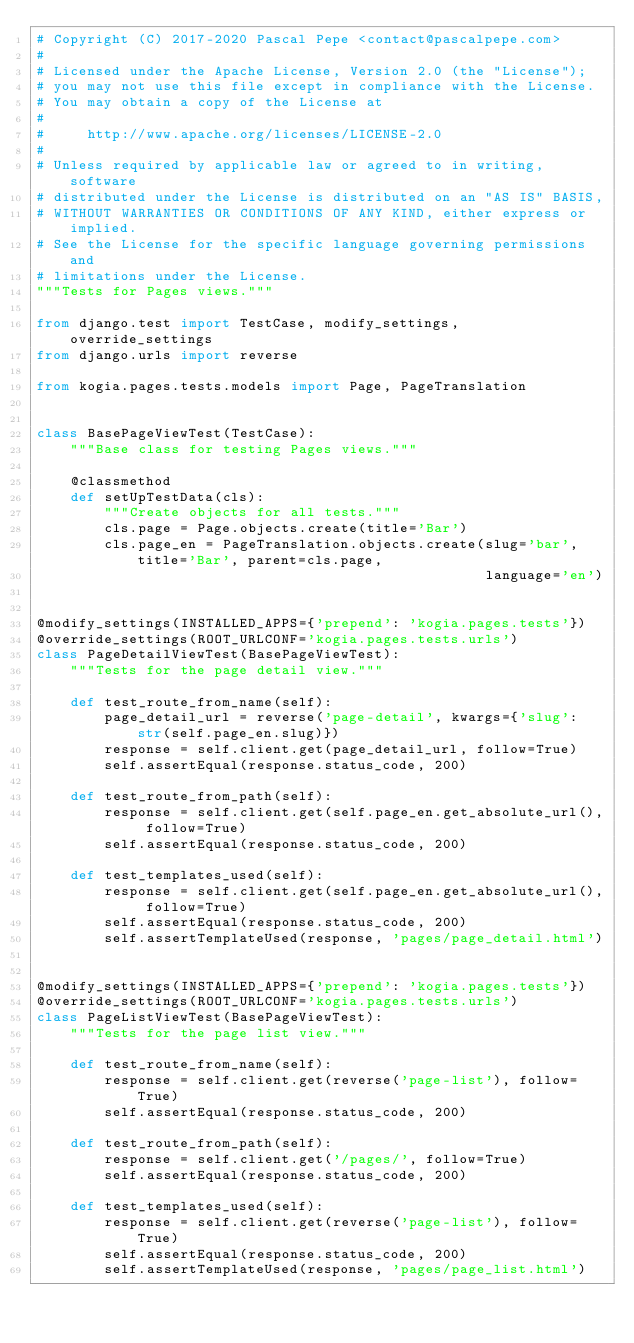Convert code to text. <code><loc_0><loc_0><loc_500><loc_500><_Python_># Copyright (C) 2017-2020 Pascal Pepe <contact@pascalpepe.com>
#
# Licensed under the Apache License, Version 2.0 (the "License");
# you may not use this file except in compliance with the License.
# You may obtain a copy of the License at
#
#     http://www.apache.org/licenses/LICENSE-2.0
#
# Unless required by applicable law or agreed to in writing, software
# distributed under the License is distributed on an "AS IS" BASIS,
# WITHOUT WARRANTIES OR CONDITIONS OF ANY KIND, either express or implied.
# See the License for the specific language governing permissions and
# limitations under the License.
"""Tests for Pages views."""

from django.test import TestCase, modify_settings, override_settings
from django.urls import reverse

from kogia.pages.tests.models import Page, PageTranslation


class BasePageViewTest(TestCase):
    """Base class for testing Pages views."""

    @classmethod
    def setUpTestData(cls):
        """Create objects for all tests."""
        cls.page = Page.objects.create(title='Bar')
        cls.page_en = PageTranslation.objects.create(slug='bar', title='Bar', parent=cls.page,
                                                     language='en')


@modify_settings(INSTALLED_APPS={'prepend': 'kogia.pages.tests'})
@override_settings(ROOT_URLCONF='kogia.pages.tests.urls')
class PageDetailViewTest(BasePageViewTest):
    """Tests for the page detail view."""

    def test_route_from_name(self):
        page_detail_url = reverse('page-detail', kwargs={'slug': str(self.page_en.slug)})
        response = self.client.get(page_detail_url, follow=True)
        self.assertEqual(response.status_code, 200)

    def test_route_from_path(self):
        response = self.client.get(self.page_en.get_absolute_url(), follow=True)
        self.assertEqual(response.status_code, 200)

    def test_templates_used(self):
        response = self.client.get(self.page_en.get_absolute_url(), follow=True)
        self.assertEqual(response.status_code, 200)
        self.assertTemplateUsed(response, 'pages/page_detail.html')


@modify_settings(INSTALLED_APPS={'prepend': 'kogia.pages.tests'})
@override_settings(ROOT_URLCONF='kogia.pages.tests.urls')
class PageListViewTest(BasePageViewTest):
    """Tests for the page list view."""

    def test_route_from_name(self):
        response = self.client.get(reverse('page-list'), follow=True)
        self.assertEqual(response.status_code, 200)

    def test_route_from_path(self):
        response = self.client.get('/pages/', follow=True)
        self.assertEqual(response.status_code, 200)

    def test_templates_used(self):
        response = self.client.get(reverse('page-list'), follow=True)
        self.assertEqual(response.status_code, 200)
        self.assertTemplateUsed(response, 'pages/page_list.html')
</code> 